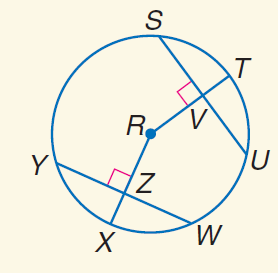Answer the mathemtical geometry problem and directly provide the correct option letter.
Question: In \odot R, S U = 20, Y W = 20, and m \widehat Y X = 45. Find m \widehat S T.
Choices: A: 20 B: 30 C: 45 D: 90 C 